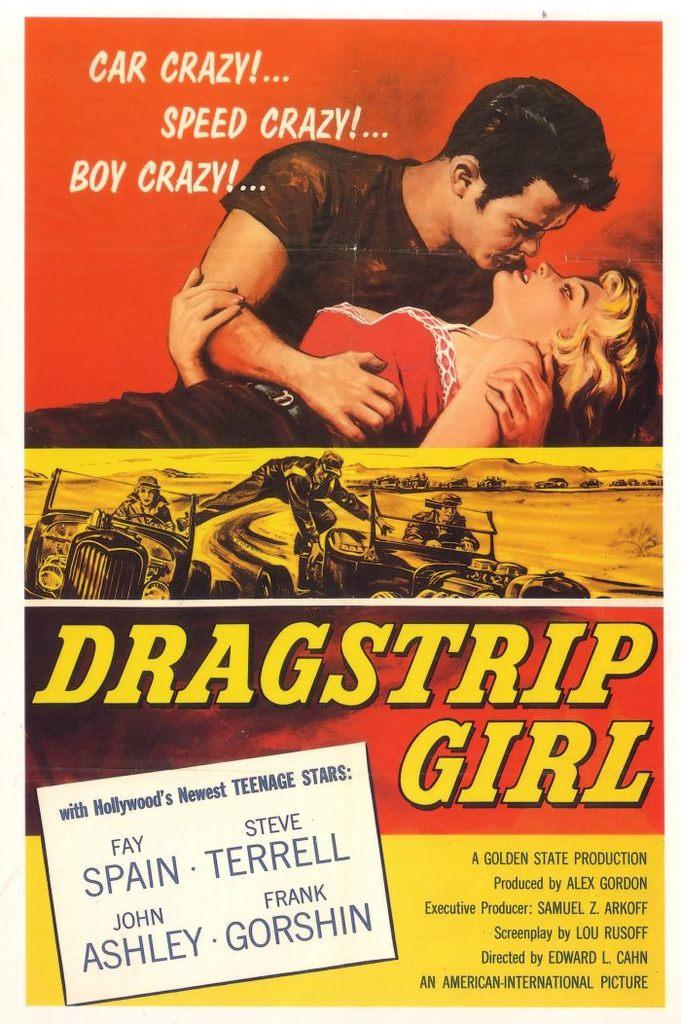What is featured in the image? There is a poster in the image. What is the main subject of the poster? The poster depicts a man holding a girl. Is there any text on the poster? Yes, there is script at the bottom of the poster. What type of comb is the man using on the girl's hair in the image? There is no comb present in the image; the man is simply holding the girl. 